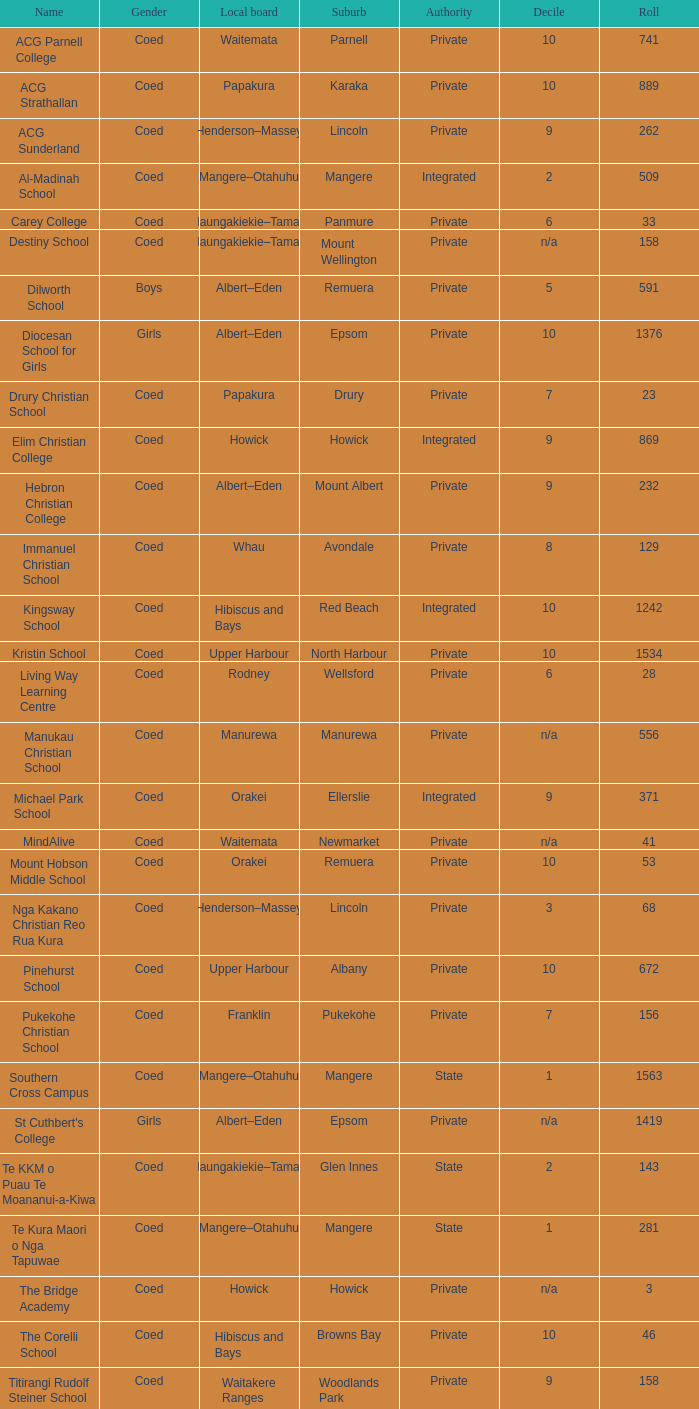Which suburb has a roll count of 741? Parnell. 